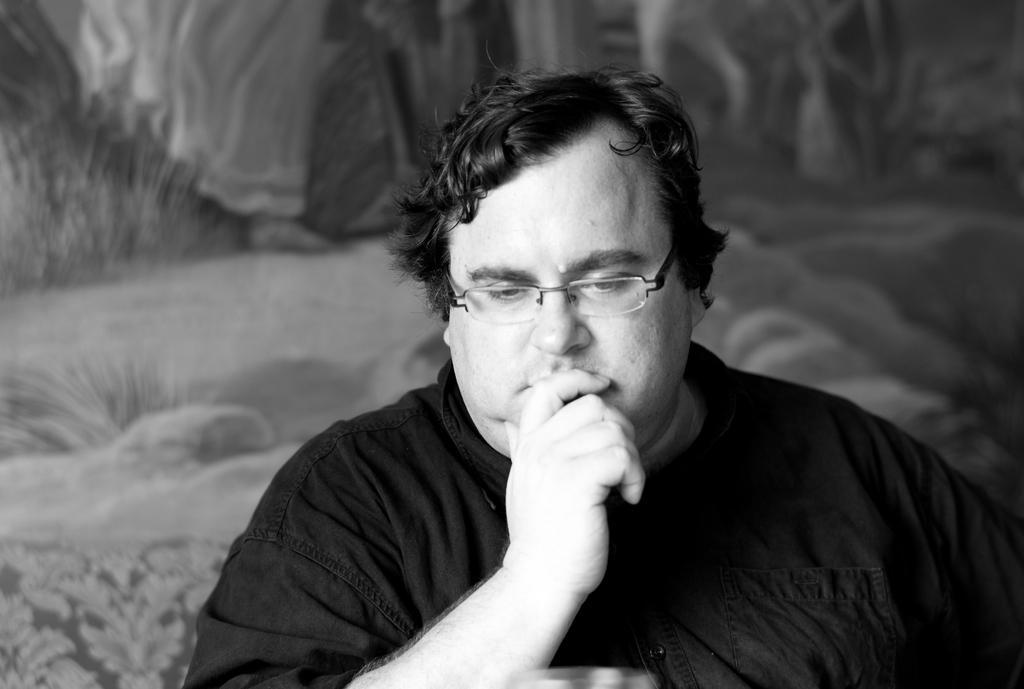How would you summarize this image in a sentence or two? In the image a person is watching. Behind him there is a wall. 